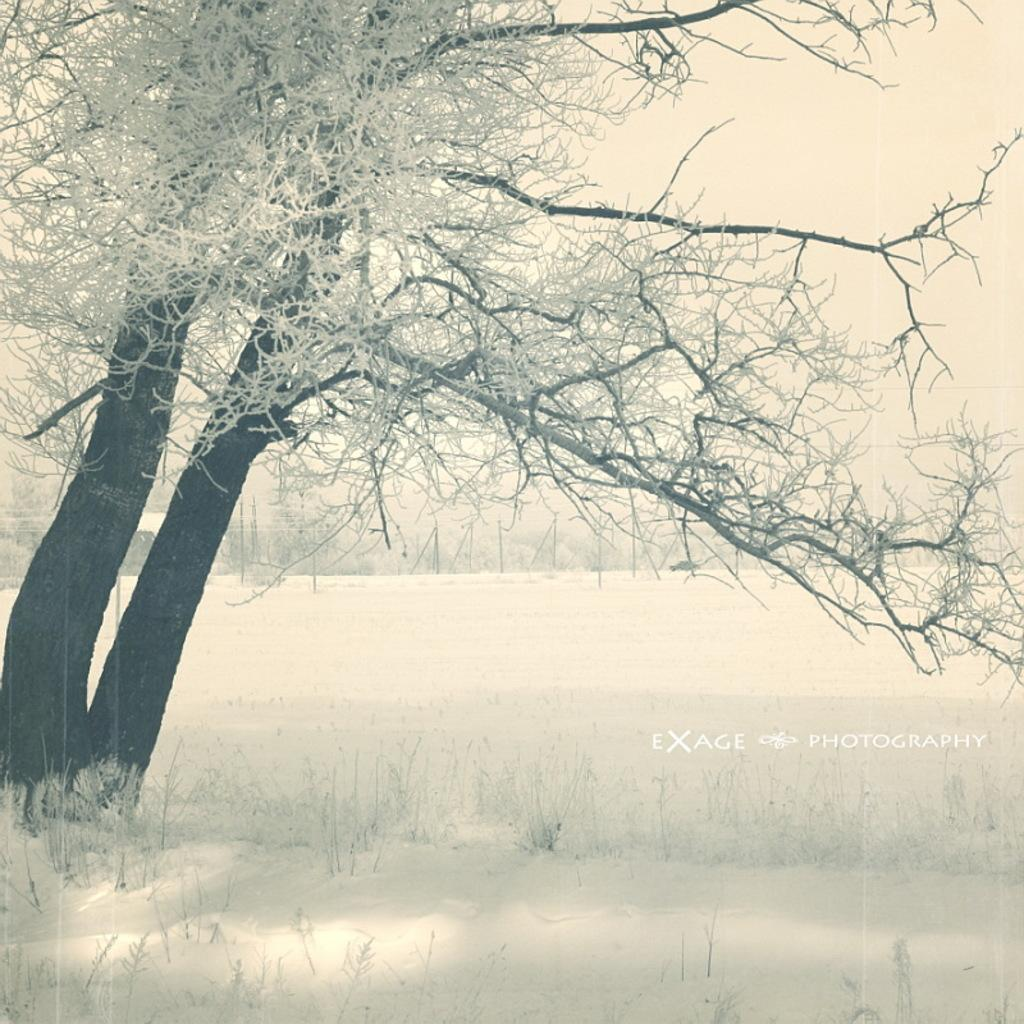What type of vegetation can be seen in the image? There are trees and grass in the image. What is the weather like in the image? The presence of snow suggests that it is a cold or wintery scene. What is visible in the sky in the image? The sky is visible in the image. Is there any additional information or marking on the image? Yes, there is a watermark on the right side of the image. What type of flower is blooming in the image? There is no flower present in the image; it features trees, grass, snow, and a visible sky. 